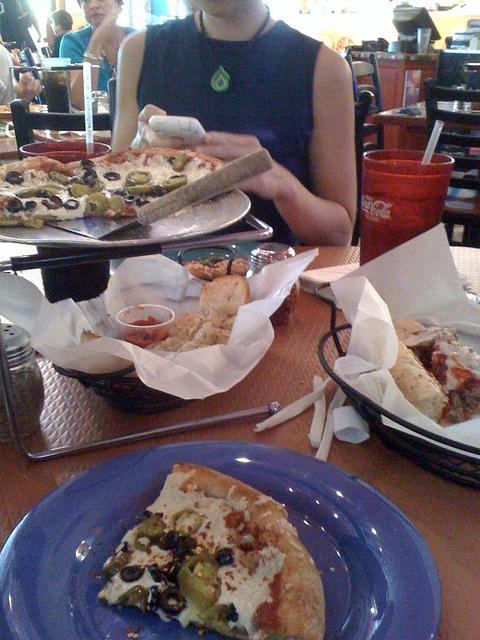What is in the thing with coke? Please explain your reasoning. straw. There is a glass of coke with a straw in it. 